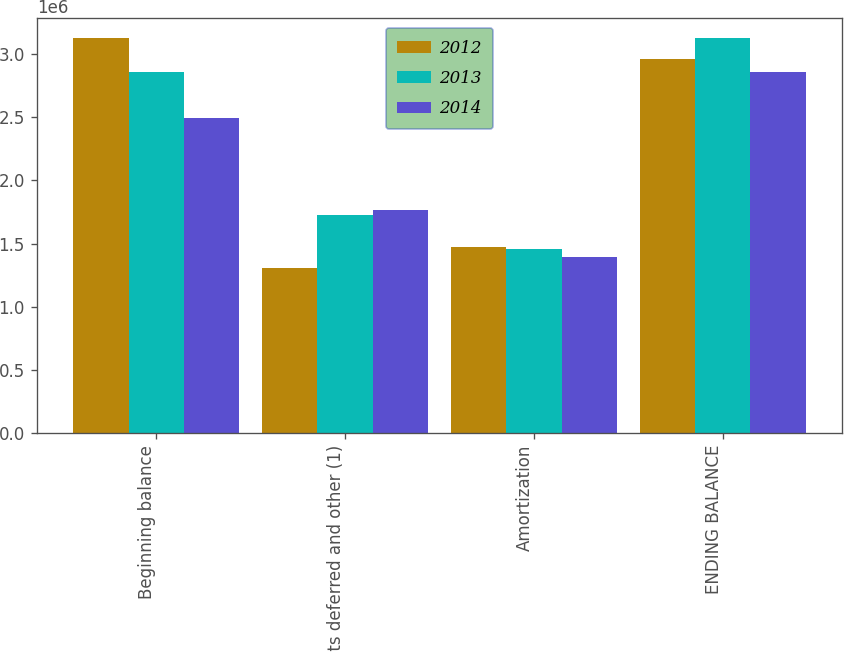Convert chart. <chart><loc_0><loc_0><loc_500><loc_500><stacked_bar_chart><ecel><fcel>Beginning balance<fcel>Costs deferred and other (1)<fcel>Amortization<fcel>ENDING BALANCE<nl><fcel>2012<fcel>3.12893e+06<fcel>1.30639e+06<fcel>1.47758e+06<fcel>2.95774e+06<nl><fcel>2013<fcel>2.86116e+06<fcel>1.72961e+06<fcel>1.46184e+06<fcel>3.12893e+06<nl><fcel>2014<fcel>2.49286e+06<fcel>1.76256e+06<fcel>1.39425e+06<fcel>2.86116e+06<nl></chart> 